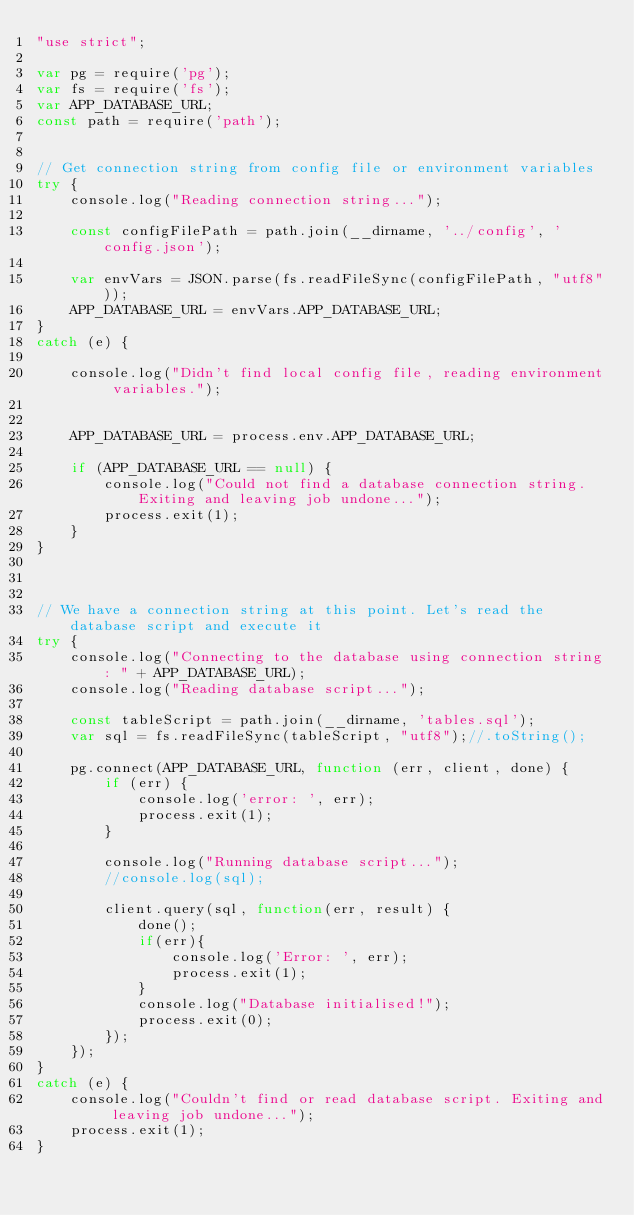Convert code to text. <code><loc_0><loc_0><loc_500><loc_500><_JavaScript_>"use strict";

var pg = require('pg');
var fs = require('fs');
var APP_DATABASE_URL;
const path = require('path');


// Get connection string from config file or environment variables
try {
    console.log("Reading connection string...");

    const configFilePath = path.join(__dirname, '../config', 'config.json');

    var envVars = JSON.parse(fs.readFileSync(configFilePath, "utf8"));
    APP_DATABASE_URL = envVars.APP_DATABASE_URL;
}
catch (e) {

    console.log("Didn't find local config file, reading environment variables.");


    APP_DATABASE_URL = process.env.APP_DATABASE_URL;

    if (APP_DATABASE_URL == null) {
        console.log("Could not find a database connection string. Exiting and leaving job undone...");
        process.exit(1);
    }
}



// We have a connection string at this point. Let's read the database script and execute it
try {
    console.log("Connecting to the database using connection string: " + APP_DATABASE_URL);
    console.log("Reading database script...");

    const tableScript = path.join(__dirname, 'tables.sql');
    var sql = fs.readFileSync(tableScript, "utf8");//.toString();

    pg.connect(APP_DATABASE_URL, function (err, client, done) {
        if (err) {
            console.log('error: ', err);
            process.exit(1);
        }

        console.log("Running database script...");
        //console.log(sql);

        client.query(sql, function(err, result) {
            done();
            if(err){
                console.log('Error: ', err);
                process.exit(1);
            }
            console.log("Database initialised!");
            process.exit(0);
        });
    });
}
catch (e) {
    console.log("Couldn't find or read database script. Exiting and leaving job undone...");
    process.exit(1);
}</code> 